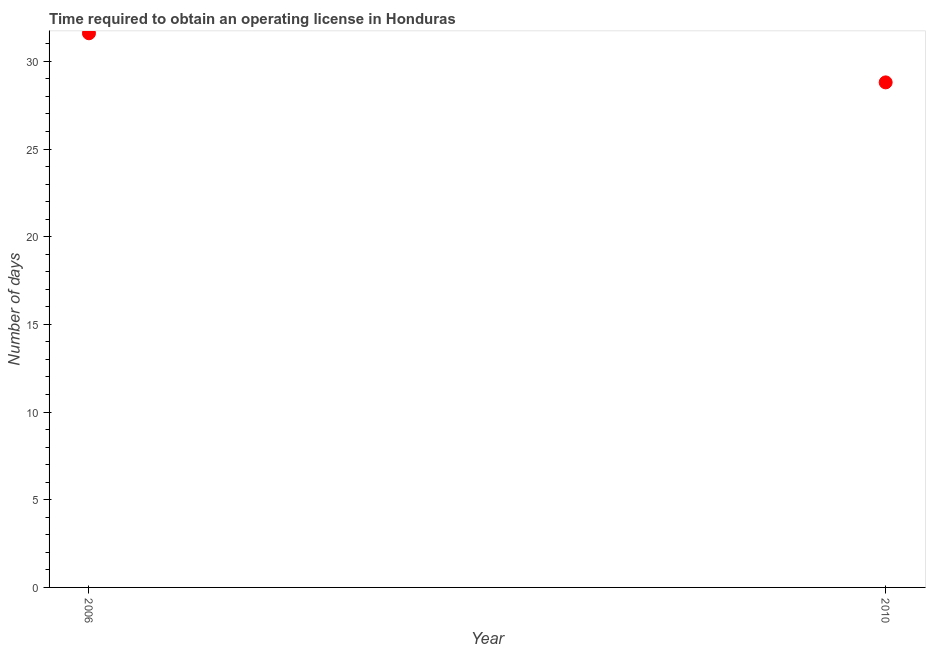What is the number of days to obtain operating license in 2006?
Ensure brevity in your answer.  31.6. Across all years, what is the maximum number of days to obtain operating license?
Ensure brevity in your answer.  31.6. Across all years, what is the minimum number of days to obtain operating license?
Give a very brief answer. 28.8. What is the sum of the number of days to obtain operating license?
Give a very brief answer. 60.4. What is the difference between the number of days to obtain operating license in 2006 and 2010?
Provide a short and direct response. 2.8. What is the average number of days to obtain operating license per year?
Provide a short and direct response. 30.2. What is the median number of days to obtain operating license?
Your response must be concise. 30.2. Do a majority of the years between 2006 and 2010 (inclusive) have number of days to obtain operating license greater than 1 days?
Offer a terse response. Yes. What is the ratio of the number of days to obtain operating license in 2006 to that in 2010?
Provide a short and direct response. 1.1. Does the number of days to obtain operating license monotonically increase over the years?
Give a very brief answer. No. How many years are there in the graph?
Your answer should be compact. 2. What is the difference between two consecutive major ticks on the Y-axis?
Offer a very short reply. 5. Are the values on the major ticks of Y-axis written in scientific E-notation?
Keep it short and to the point. No. Does the graph contain any zero values?
Your answer should be compact. No. What is the title of the graph?
Your answer should be compact. Time required to obtain an operating license in Honduras. What is the label or title of the X-axis?
Provide a short and direct response. Year. What is the label or title of the Y-axis?
Your answer should be very brief. Number of days. What is the Number of days in 2006?
Offer a terse response. 31.6. What is the Number of days in 2010?
Ensure brevity in your answer.  28.8. What is the ratio of the Number of days in 2006 to that in 2010?
Give a very brief answer. 1.1. 